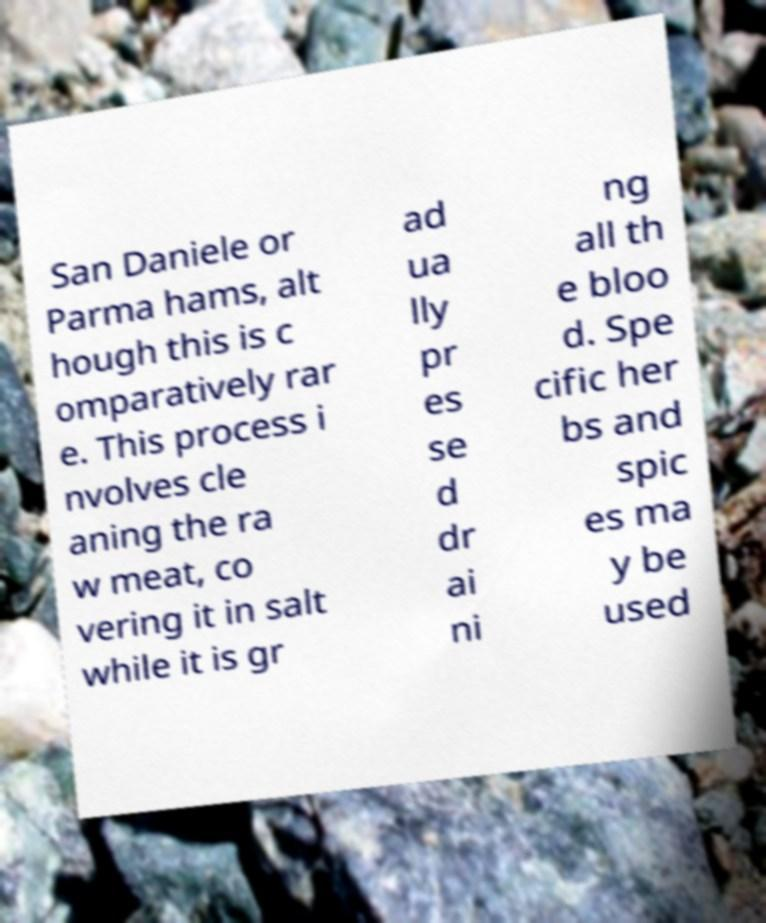Please read and relay the text visible in this image. What does it say? San Daniele or Parma hams, alt hough this is c omparatively rar e. This process i nvolves cle aning the ra w meat, co vering it in salt while it is gr ad ua lly pr es se d dr ai ni ng all th e bloo d. Spe cific her bs and spic es ma y be used 